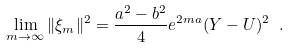<formula> <loc_0><loc_0><loc_500><loc_500>\lim _ { m \rightarrow \infty } \| { \xi } _ { m } \| ^ { 2 } = \frac { a ^ { 2 } - b ^ { 2 } } { 4 } e ^ { 2 m a } ( Y - U ) ^ { 2 } \ .</formula> 